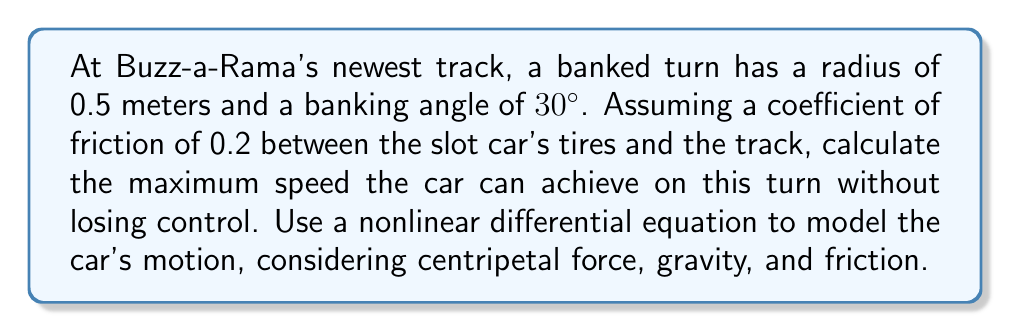Teach me how to tackle this problem. Let's approach this step-by-step:

1) First, we need to set up a nonlinear differential equation that describes the car's motion on the banked turn. We'll use polar coordinates $(r, \theta)$ where $r$ is the radius of the turn and $\theta$ is the angular position.

2) The forces acting on the car are:
   - Centripetal force: $F_c = m\frac{v^2}{r}$
   - Component of gravity perpendicular to the track: $F_g = mg\cos(30°)$
   - Friction force: $F_f = \mu N$, where $N$ is the normal force

3) The normal force is given by:
   $$N = mg\sin(30°) + m\frac{v^2}{r}\cos(30°)$$

4) The equation of motion in the radial direction is:
   $$m\frac{v^2}{r} = mg\sin(30°) + \mu(mg\sin(30°) + m\frac{v^2}{r}\cos(30°))$$

5) This can be rewritten as a nonlinear differential equation:
   $$r\ddot{\theta}^2 = g\sin(30°) + \mu(g\sin(30°) + r\ddot{\theta}^2\cos(30°))$$

6) To find the maximum speed, we need to solve for $\dot{\theta}$ when $\ddot{\theta} = 0$ (constant angular velocity):
   $$r\dot{\theta}^2 = g\sin(30°) + \mu(g\sin(30°) + r\dot{\theta}^2\cos(30°))$$

7) Solving this equation for $\dot{\theta}$:
   $$\dot{\theta} = \sqrt{\frac{g\sin(30°)(1+\mu)}{r(1-\mu\cos(30°))}}$$

8) The linear speed $v$ is related to $\dot{\theta}$ by $v = r\dot{\theta}$. Substituting the given values:
   $$v = 0.5 \sqrt{\frac{9.8 \cdot 0.5(1+0.2)}{0.5(1-0.2\cdot 0.866)}} \approx 1.92 \text{ m/s}$$

9) Converting to km/h:
   $$v \approx 1.92 \cdot 3.6 \approx 6.91 \text{ km/h}$$
Answer: 6.91 km/h 